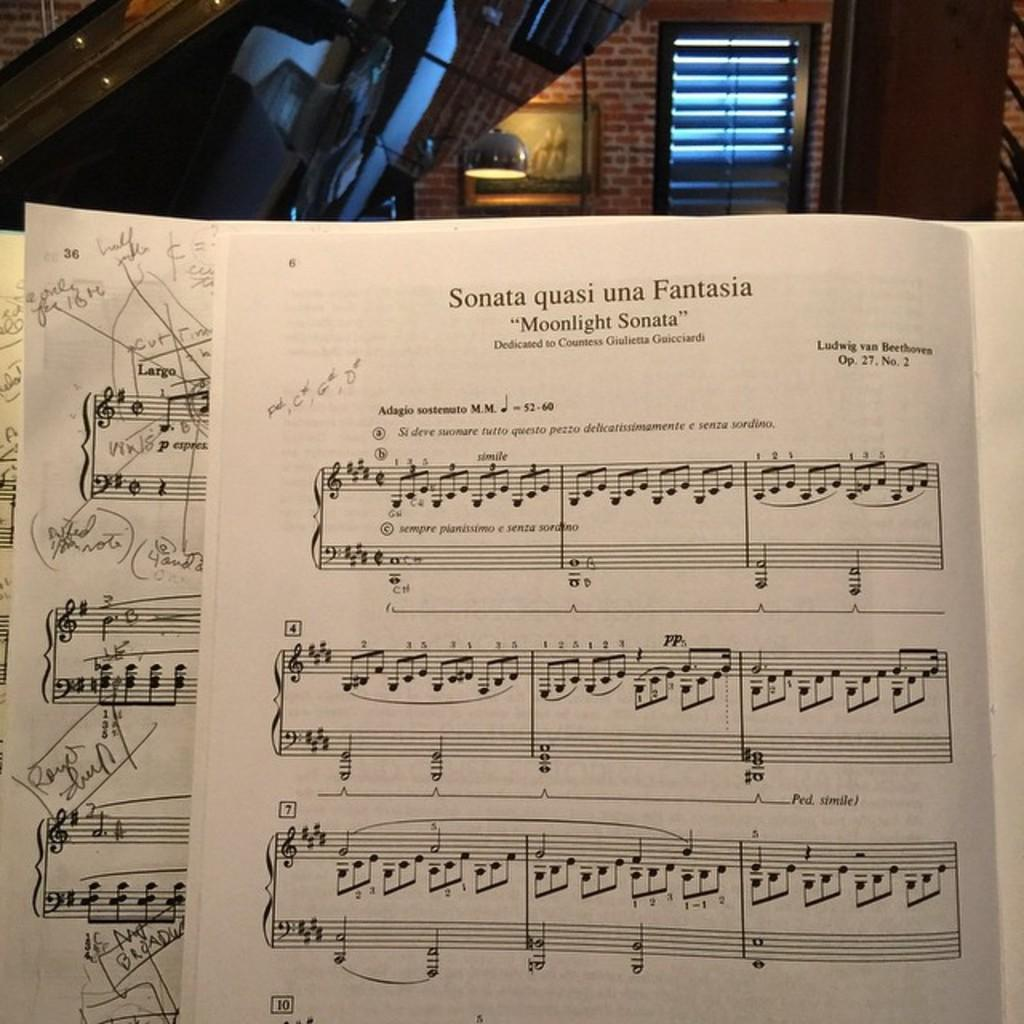What is depicted on the sheet music in the image? The sheet music has text on it. What is located on the backside of the sheet music? There is a musical instrument on the backside of the sheet music. What architectural feature can be seen in the image? There is a window in the image. What type of decorative item is present on a wall in the image? There is a photo frame on a wall in the image. What type of lighting is present in the image? There is a lamp in the image. What type of utensil is used to play the musical instrument in the image? There are no utensils mentioned or depicted in the image; the musical instrument is likely played with fingers or a bow. 